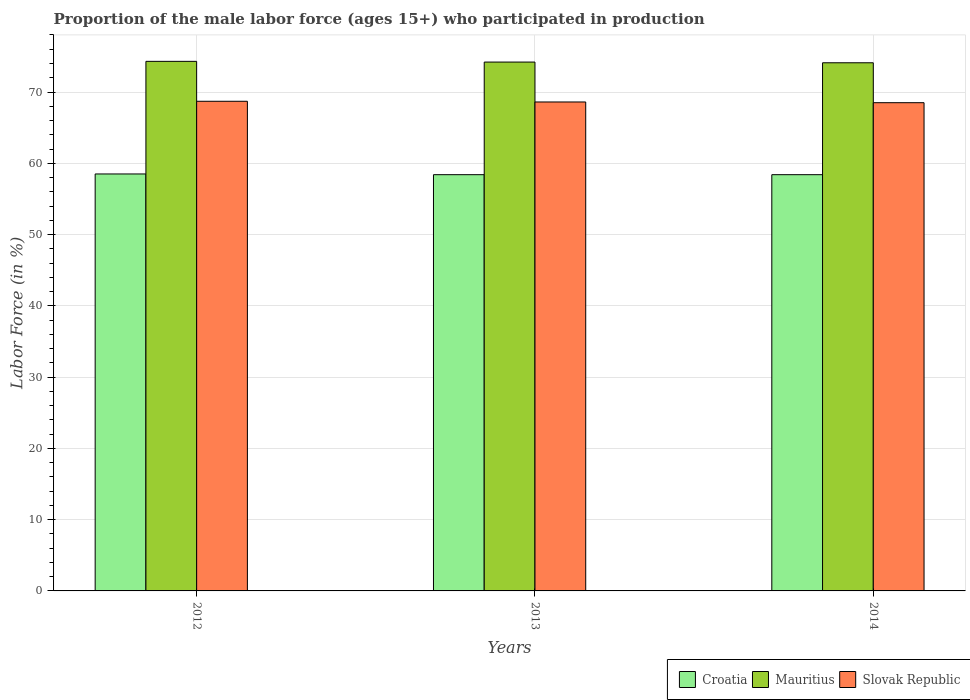How many different coloured bars are there?
Your answer should be compact. 3. Are the number of bars per tick equal to the number of legend labels?
Your response must be concise. Yes. Are the number of bars on each tick of the X-axis equal?
Make the answer very short. Yes. How many bars are there on the 1st tick from the right?
Ensure brevity in your answer.  3. What is the label of the 1st group of bars from the left?
Keep it short and to the point. 2012. What is the proportion of the male labor force who participated in production in Mauritius in 2014?
Offer a terse response. 74.1. Across all years, what is the maximum proportion of the male labor force who participated in production in Slovak Republic?
Provide a succinct answer. 68.7. Across all years, what is the minimum proportion of the male labor force who participated in production in Slovak Republic?
Keep it short and to the point. 68.5. In which year was the proportion of the male labor force who participated in production in Mauritius maximum?
Make the answer very short. 2012. In which year was the proportion of the male labor force who participated in production in Croatia minimum?
Provide a short and direct response. 2013. What is the total proportion of the male labor force who participated in production in Slovak Republic in the graph?
Offer a very short reply. 205.8. What is the difference between the proportion of the male labor force who participated in production in Mauritius in 2013 and that in 2014?
Give a very brief answer. 0.1. What is the difference between the proportion of the male labor force who participated in production in Croatia in 2014 and the proportion of the male labor force who participated in production in Mauritius in 2012?
Provide a succinct answer. -15.9. What is the average proportion of the male labor force who participated in production in Mauritius per year?
Make the answer very short. 74.2. In the year 2012, what is the difference between the proportion of the male labor force who participated in production in Slovak Republic and proportion of the male labor force who participated in production in Mauritius?
Provide a short and direct response. -5.6. In how many years, is the proportion of the male labor force who participated in production in Slovak Republic greater than 70 %?
Offer a very short reply. 0. What is the ratio of the proportion of the male labor force who participated in production in Croatia in 2012 to that in 2014?
Keep it short and to the point. 1. Is the proportion of the male labor force who participated in production in Croatia in 2012 less than that in 2014?
Make the answer very short. No. What is the difference between the highest and the second highest proportion of the male labor force who participated in production in Slovak Republic?
Offer a terse response. 0.1. What is the difference between the highest and the lowest proportion of the male labor force who participated in production in Mauritius?
Your answer should be very brief. 0.2. In how many years, is the proportion of the male labor force who participated in production in Croatia greater than the average proportion of the male labor force who participated in production in Croatia taken over all years?
Offer a terse response. 1. Is the sum of the proportion of the male labor force who participated in production in Slovak Republic in 2012 and 2014 greater than the maximum proportion of the male labor force who participated in production in Croatia across all years?
Your answer should be very brief. Yes. What does the 3rd bar from the left in 2014 represents?
Your answer should be compact. Slovak Republic. What does the 2nd bar from the right in 2013 represents?
Provide a short and direct response. Mauritius. How many years are there in the graph?
Ensure brevity in your answer.  3. What is the difference between two consecutive major ticks on the Y-axis?
Your response must be concise. 10. Where does the legend appear in the graph?
Your response must be concise. Bottom right. How many legend labels are there?
Ensure brevity in your answer.  3. How are the legend labels stacked?
Your answer should be very brief. Horizontal. What is the title of the graph?
Provide a short and direct response. Proportion of the male labor force (ages 15+) who participated in production. Does "Greenland" appear as one of the legend labels in the graph?
Ensure brevity in your answer.  No. What is the label or title of the Y-axis?
Ensure brevity in your answer.  Labor Force (in %). What is the Labor Force (in %) in Croatia in 2012?
Offer a very short reply. 58.5. What is the Labor Force (in %) of Mauritius in 2012?
Offer a terse response. 74.3. What is the Labor Force (in %) of Slovak Republic in 2012?
Keep it short and to the point. 68.7. What is the Labor Force (in %) in Croatia in 2013?
Offer a very short reply. 58.4. What is the Labor Force (in %) in Mauritius in 2013?
Give a very brief answer. 74.2. What is the Labor Force (in %) of Slovak Republic in 2013?
Provide a short and direct response. 68.6. What is the Labor Force (in %) in Croatia in 2014?
Provide a succinct answer. 58.4. What is the Labor Force (in %) of Mauritius in 2014?
Your answer should be compact. 74.1. What is the Labor Force (in %) of Slovak Republic in 2014?
Offer a very short reply. 68.5. Across all years, what is the maximum Labor Force (in %) of Croatia?
Your response must be concise. 58.5. Across all years, what is the maximum Labor Force (in %) of Mauritius?
Ensure brevity in your answer.  74.3. Across all years, what is the maximum Labor Force (in %) of Slovak Republic?
Provide a succinct answer. 68.7. Across all years, what is the minimum Labor Force (in %) in Croatia?
Give a very brief answer. 58.4. Across all years, what is the minimum Labor Force (in %) in Mauritius?
Your answer should be very brief. 74.1. Across all years, what is the minimum Labor Force (in %) in Slovak Republic?
Give a very brief answer. 68.5. What is the total Labor Force (in %) in Croatia in the graph?
Your answer should be compact. 175.3. What is the total Labor Force (in %) in Mauritius in the graph?
Your answer should be very brief. 222.6. What is the total Labor Force (in %) of Slovak Republic in the graph?
Keep it short and to the point. 205.8. What is the difference between the Labor Force (in %) of Mauritius in 2012 and that in 2013?
Your response must be concise. 0.1. What is the difference between the Labor Force (in %) in Croatia in 2012 and that in 2014?
Make the answer very short. 0.1. What is the difference between the Labor Force (in %) of Mauritius in 2012 and that in 2014?
Keep it short and to the point. 0.2. What is the difference between the Labor Force (in %) in Slovak Republic in 2012 and that in 2014?
Ensure brevity in your answer.  0.2. What is the difference between the Labor Force (in %) of Mauritius in 2013 and that in 2014?
Your answer should be very brief. 0.1. What is the difference between the Labor Force (in %) in Croatia in 2012 and the Labor Force (in %) in Mauritius in 2013?
Ensure brevity in your answer.  -15.7. What is the difference between the Labor Force (in %) in Croatia in 2012 and the Labor Force (in %) in Slovak Republic in 2013?
Offer a very short reply. -10.1. What is the difference between the Labor Force (in %) of Mauritius in 2012 and the Labor Force (in %) of Slovak Republic in 2013?
Provide a short and direct response. 5.7. What is the difference between the Labor Force (in %) of Croatia in 2012 and the Labor Force (in %) of Mauritius in 2014?
Your answer should be very brief. -15.6. What is the difference between the Labor Force (in %) in Croatia in 2012 and the Labor Force (in %) in Slovak Republic in 2014?
Your answer should be very brief. -10. What is the difference between the Labor Force (in %) of Mauritius in 2012 and the Labor Force (in %) of Slovak Republic in 2014?
Offer a terse response. 5.8. What is the difference between the Labor Force (in %) of Croatia in 2013 and the Labor Force (in %) of Mauritius in 2014?
Provide a succinct answer. -15.7. What is the difference between the Labor Force (in %) of Croatia in 2013 and the Labor Force (in %) of Slovak Republic in 2014?
Your answer should be very brief. -10.1. What is the average Labor Force (in %) in Croatia per year?
Ensure brevity in your answer.  58.43. What is the average Labor Force (in %) in Mauritius per year?
Your answer should be compact. 74.2. What is the average Labor Force (in %) in Slovak Republic per year?
Make the answer very short. 68.6. In the year 2012, what is the difference between the Labor Force (in %) in Croatia and Labor Force (in %) in Mauritius?
Make the answer very short. -15.8. In the year 2013, what is the difference between the Labor Force (in %) of Croatia and Labor Force (in %) of Mauritius?
Offer a terse response. -15.8. In the year 2013, what is the difference between the Labor Force (in %) in Croatia and Labor Force (in %) in Slovak Republic?
Provide a succinct answer. -10.2. In the year 2014, what is the difference between the Labor Force (in %) of Croatia and Labor Force (in %) of Mauritius?
Your answer should be compact. -15.7. In the year 2014, what is the difference between the Labor Force (in %) of Croatia and Labor Force (in %) of Slovak Republic?
Your answer should be compact. -10.1. In the year 2014, what is the difference between the Labor Force (in %) of Mauritius and Labor Force (in %) of Slovak Republic?
Make the answer very short. 5.6. What is the ratio of the Labor Force (in %) in Croatia in 2012 to that in 2013?
Offer a very short reply. 1. What is the ratio of the Labor Force (in %) of Mauritius in 2012 to that in 2013?
Provide a short and direct response. 1. What is the ratio of the Labor Force (in %) of Croatia in 2012 to that in 2014?
Provide a succinct answer. 1. What is the ratio of the Labor Force (in %) of Mauritius in 2012 to that in 2014?
Provide a short and direct response. 1. What is the ratio of the Labor Force (in %) in Croatia in 2013 to that in 2014?
Your response must be concise. 1. What is the ratio of the Labor Force (in %) of Slovak Republic in 2013 to that in 2014?
Provide a short and direct response. 1. What is the difference between the highest and the second highest Labor Force (in %) in Croatia?
Make the answer very short. 0.1. What is the difference between the highest and the second highest Labor Force (in %) in Mauritius?
Your answer should be compact. 0.1. What is the difference between the highest and the second highest Labor Force (in %) in Slovak Republic?
Give a very brief answer. 0.1. What is the difference between the highest and the lowest Labor Force (in %) of Croatia?
Provide a succinct answer. 0.1. What is the difference between the highest and the lowest Labor Force (in %) of Mauritius?
Make the answer very short. 0.2. 